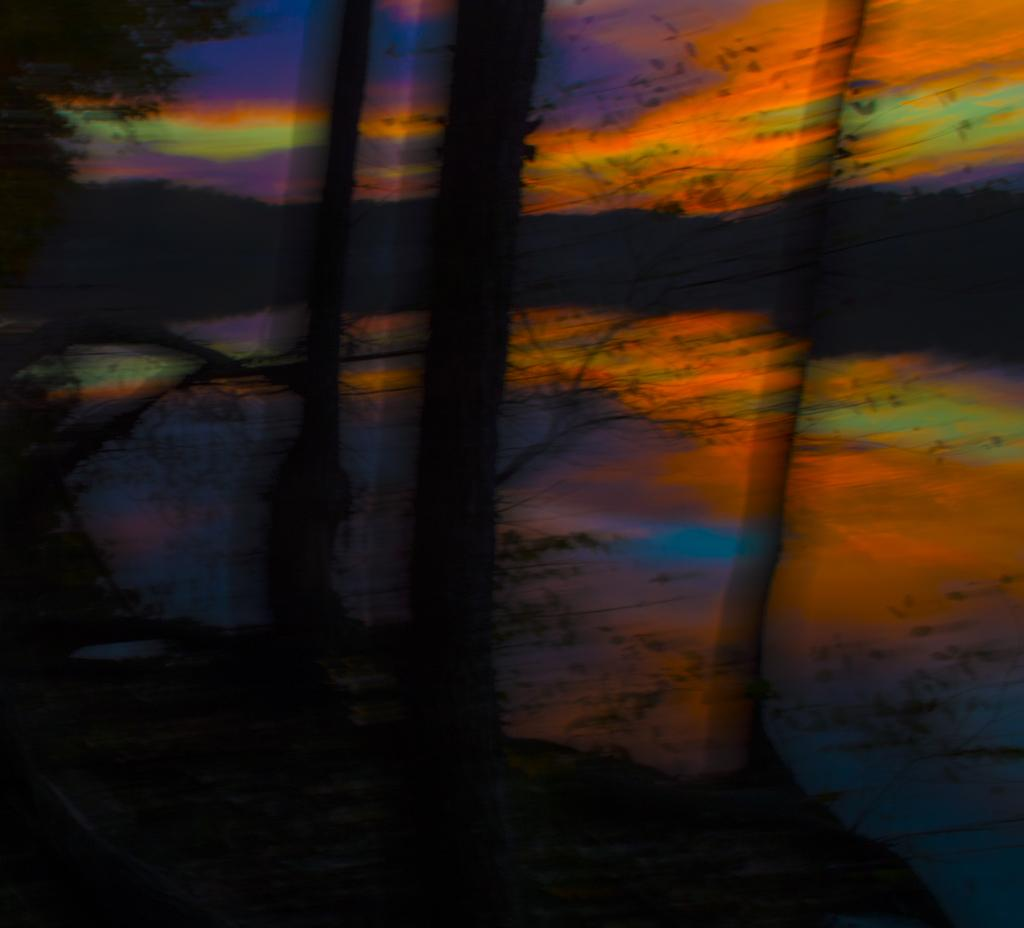What can be seen at the bottom of the image? The ground is visible in the image. What type of vegetation is in the background of the image? There are trees in the background of the image. What else can be seen in the background of the image? The sky is visible in the background of the image. What type of lettuce is growing on the ground in the image? There is no lettuce present in the image; only the ground, trees, and sky are visible. Can you tell me how many flowers are in the image? There are no flowers present in the image. 